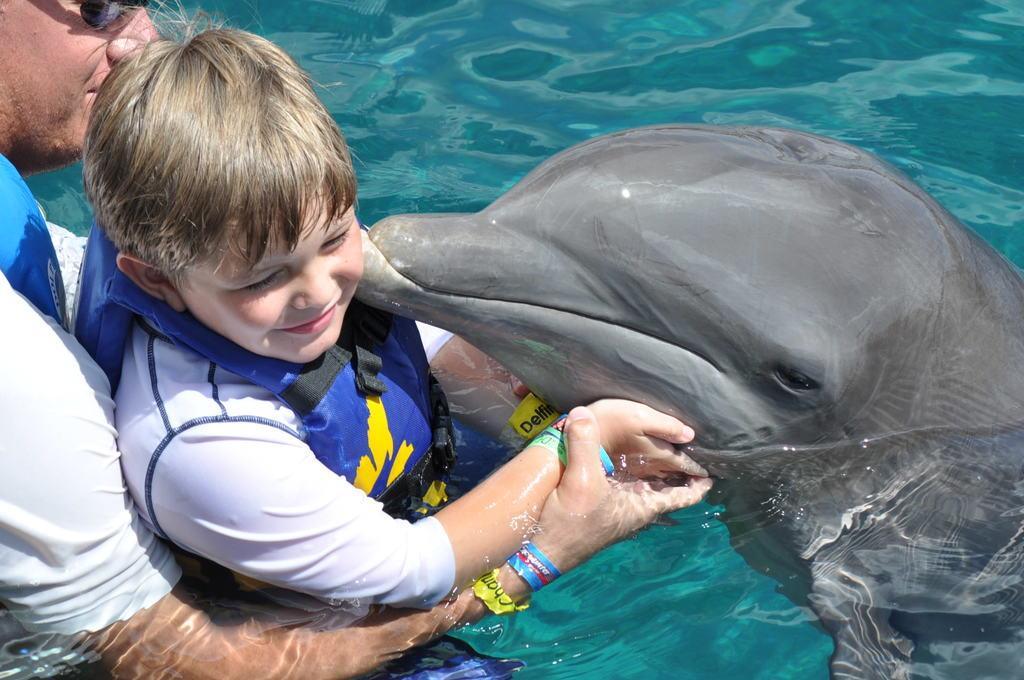Describe this image in one or two sentences. The image is taken in the pool. On the left side there is a man holding a boy in his hands. On the right there is a shark. There are water. 